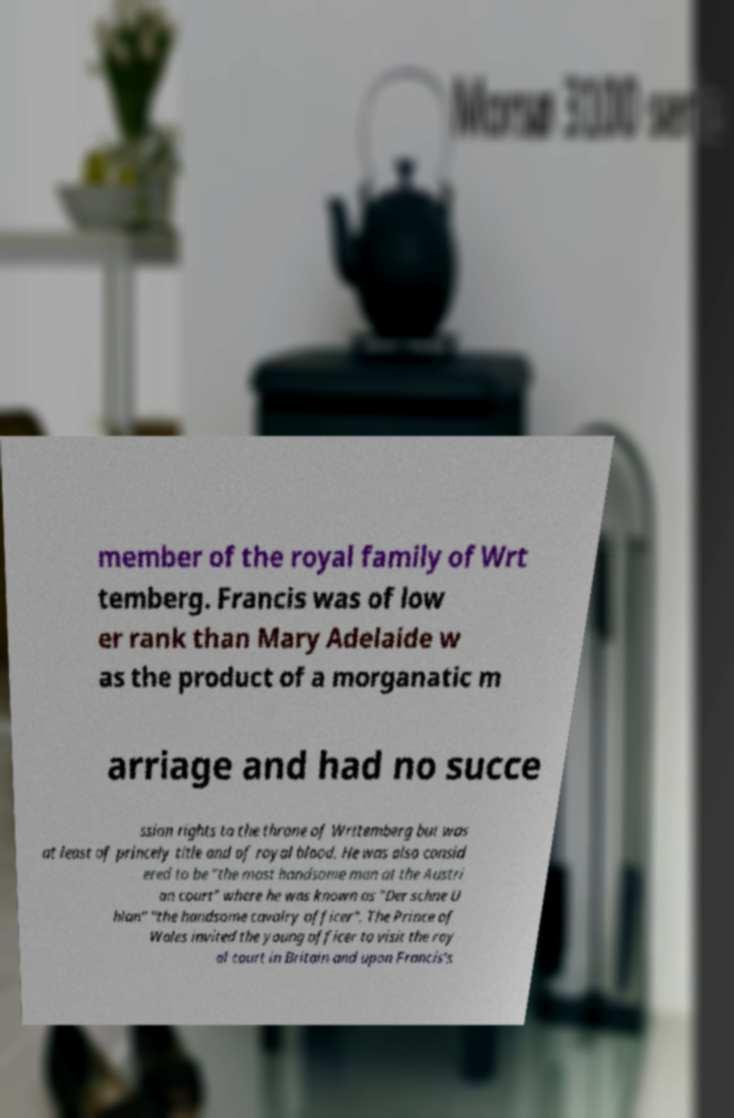Could you extract and type out the text from this image? member of the royal family of Wrt temberg. Francis was of low er rank than Mary Adelaide w as the product of a morganatic m arriage and had no succe ssion rights to the throne of Wrttemberg but was at least of princely title and of royal blood. He was also consid ered to be "the most handsome man at the Austri an court" where he was known as "Der schne U hlan" "the handsome cavalry officer". The Prince of Wales invited the young officer to visit the roy al court in Britain and upon Francis's 